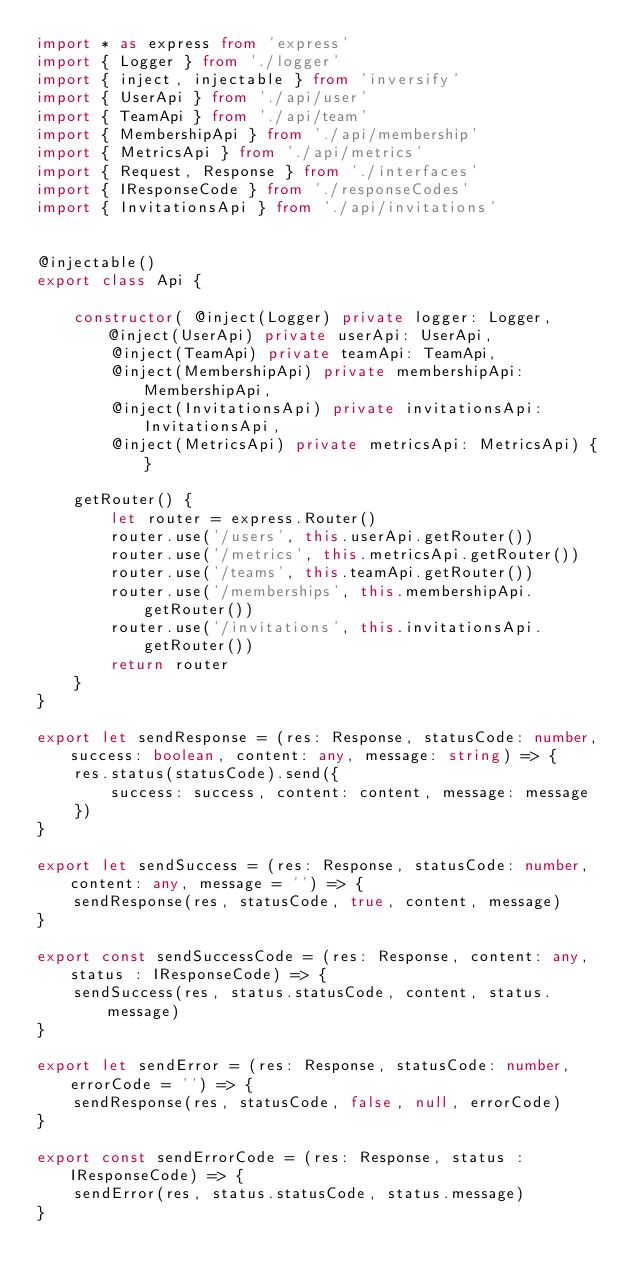Convert code to text. <code><loc_0><loc_0><loc_500><loc_500><_TypeScript_>import * as express from 'express'
import { Logger } from './logger'
import { inject, injectable } from 'inversify'
import { UserApi } from './api/user'
import { TeamApi } from './api/team'
import { MembershipApi } from './api/membership'
import { MetricsApi } from './api/metrics'
import { Request, Response } from './interfaces'
import { IResponseCode } from './responseCodes'
import { InvitationsApi } from './api/invitations'


@injectable()
export class Api {

    constructor( @inject(Logger) private logger: Logger, @inject(UserApi) private userApi: UserApi,
        @inject(TeamApi) private teamApi: TeamApi,
        @inject(MembershipApi) private membershipApi: MembershipApi,
        @inject(InvitationsApi) private invitationsApi: InvitationsApi,
        @inject(MetricsApi) private metricsApi: MetricsApi) { }

    getRouter() {
        let router = express.Router()
        router.use('/users', this.userApi.getRouter())
        router.use('/metrics', this.metricsApi.getRouter())
        router.use('/teams', this.teamApi.getRouter())
        router.use('/memberships', this.membershipApi.getRouter())
        router.use('/invitations', this.invitationsApi.getRouter())
        return router
    }
}

export let sendResponse = (res: Response, statusCode: number, success: boolean, content: any, message: string) => {
    res.status(statusCode).send({
        success: success, content: content, message: message
    })
}

export let sendSuccess = (res: Response, statusCode: number, content: any, message = '') => {
    sendResponse(res, statusCode, true, content, message)
}

export const sendSuccessCode = (res: Response, content: any, status : IResponseCode) => {
    sendSuccess(res, status.statusCode, content, status.message)
}

export let sendError = (res: Response, statusCode: number, errorCode = '') => {
    sendResponse(res, statusCode, false, null, errorCode)
}

export const sendErrorCode = (res: Response, status : IResponseCode) => {
    sendError(res, status.statusCode, status.message)
}</code> 